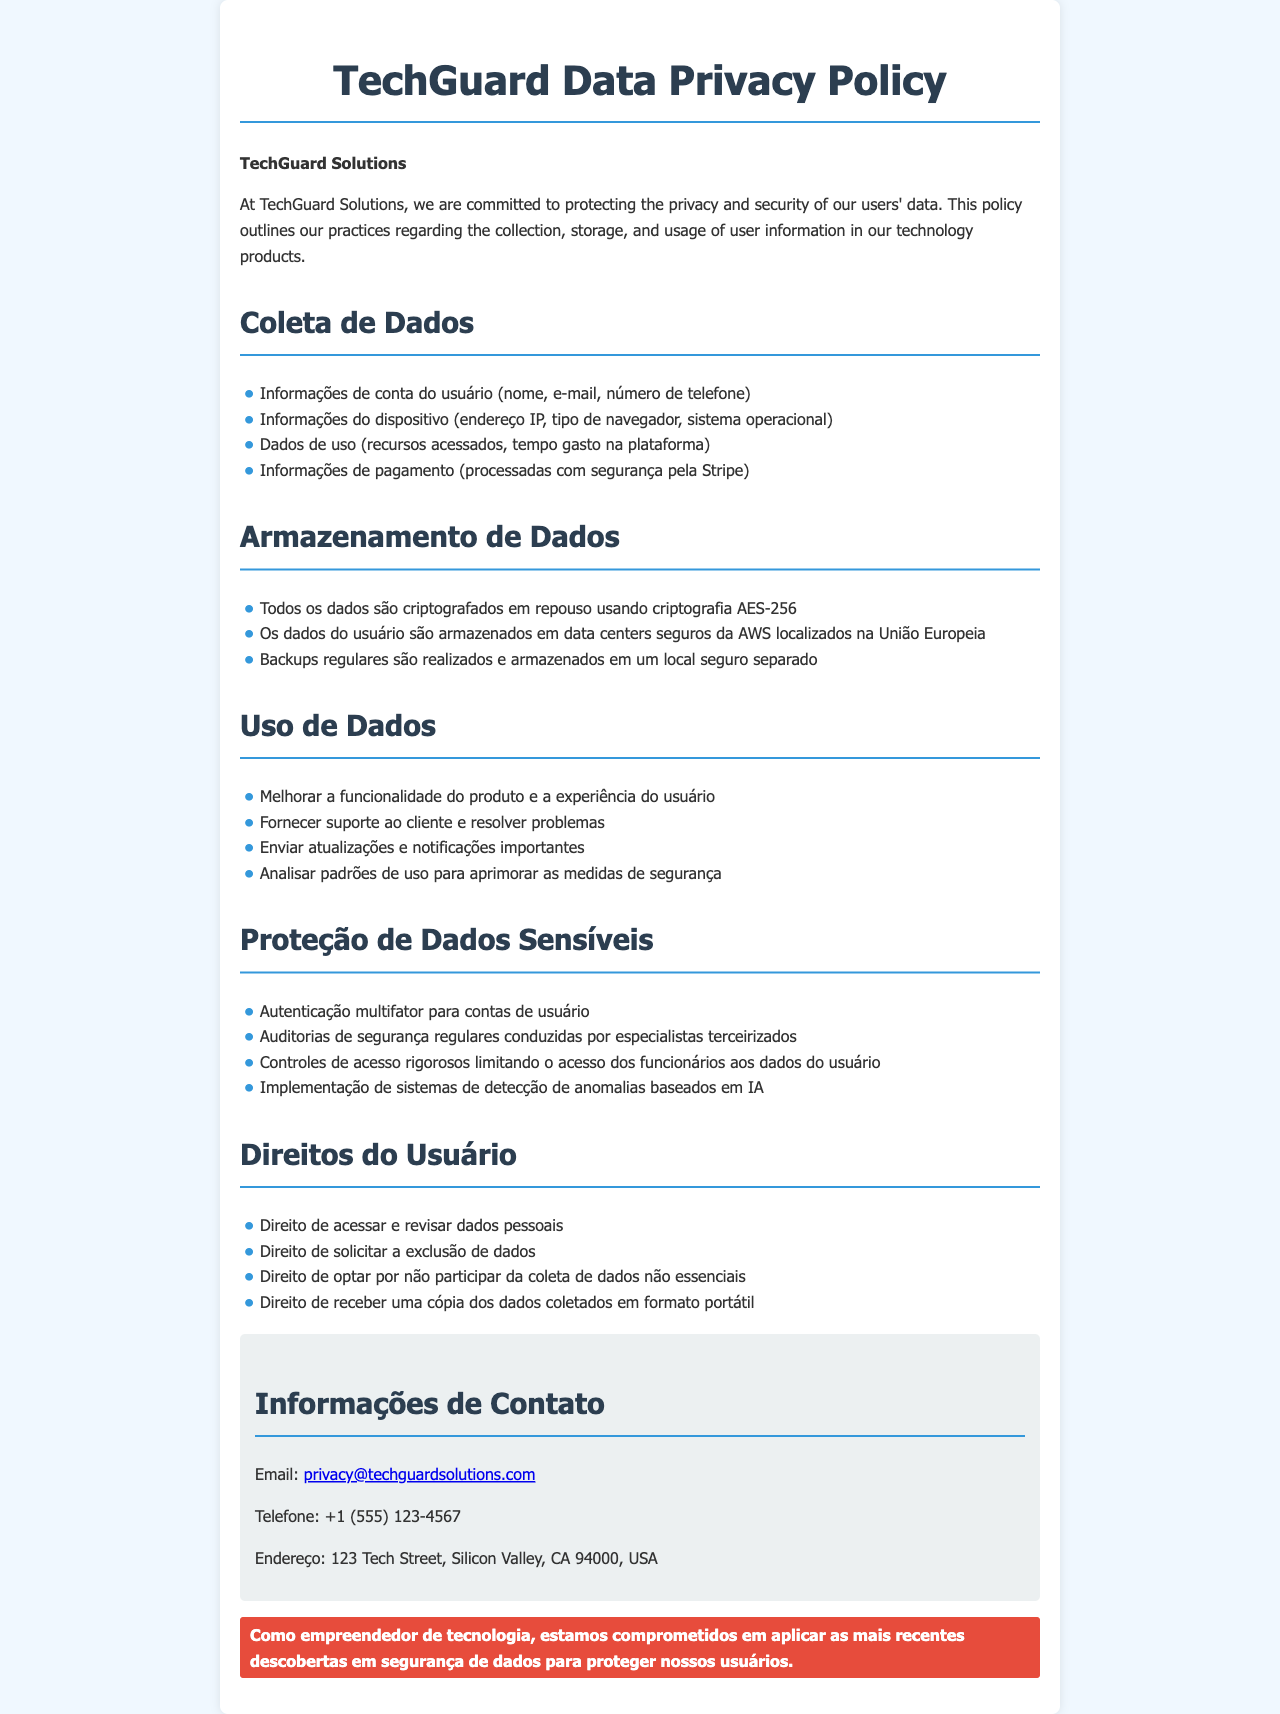Qual é o nome da empresa? O documento menciona o nome da empresa responsável pela política de privacidade, que é "TechGuard Solutions".
Answer: TechGuard Solutions Quais informações de conta são coletadas? A seção de coleta de dados lista as informações coletadas, incluindo "nome, e-mail, número de telefone".
Answer: Nome, e-mail, número de telefone Onde os dados dos usuários são armazenados? O documento especifica que os dados dos usuários são armazenados em "data centers seguros da AWS localizados na União Europeia".
Answer: União Europeia Qual método de criptografia é utilizado para armazenar dados? O documento menciona que os dados são criptografados usando "criptografia AES-256".
Answer: Criptografia AES-256 Que tipos de proteções são implementadas para dados sensíveis? A seção de proteção de dados sensíveis destaca várias medidas, incluindo "autenticação multifator".
Answer: Autenticação multifator Quantos direitos do usuário são listados? O documento lista os direitos do usuário, e conta-se um total de quatro direitos enumerados.
Answer: Quatro Qual método é utilizado para analisar padrões de uso? A política menciona que a análise de padrões de uso é feita através de "analisar padrões de uso para aprimorar as medidas de segurança".
Answer: Analisar padrões de uso Qual é o endereço de contato para dúvidas sobre privacidade? O documento fornece uma seção com informações de contato, incluindo um endereço de email que pode ser utilizado.
Answer: privacy@techguardsolutions.com Que tipo de dados de pagamento são coletados? Na seção de coleta de dados, é mencionado que as "informações de pagamento" são coletadas e processadas.
Answer: Informações de pagamento 